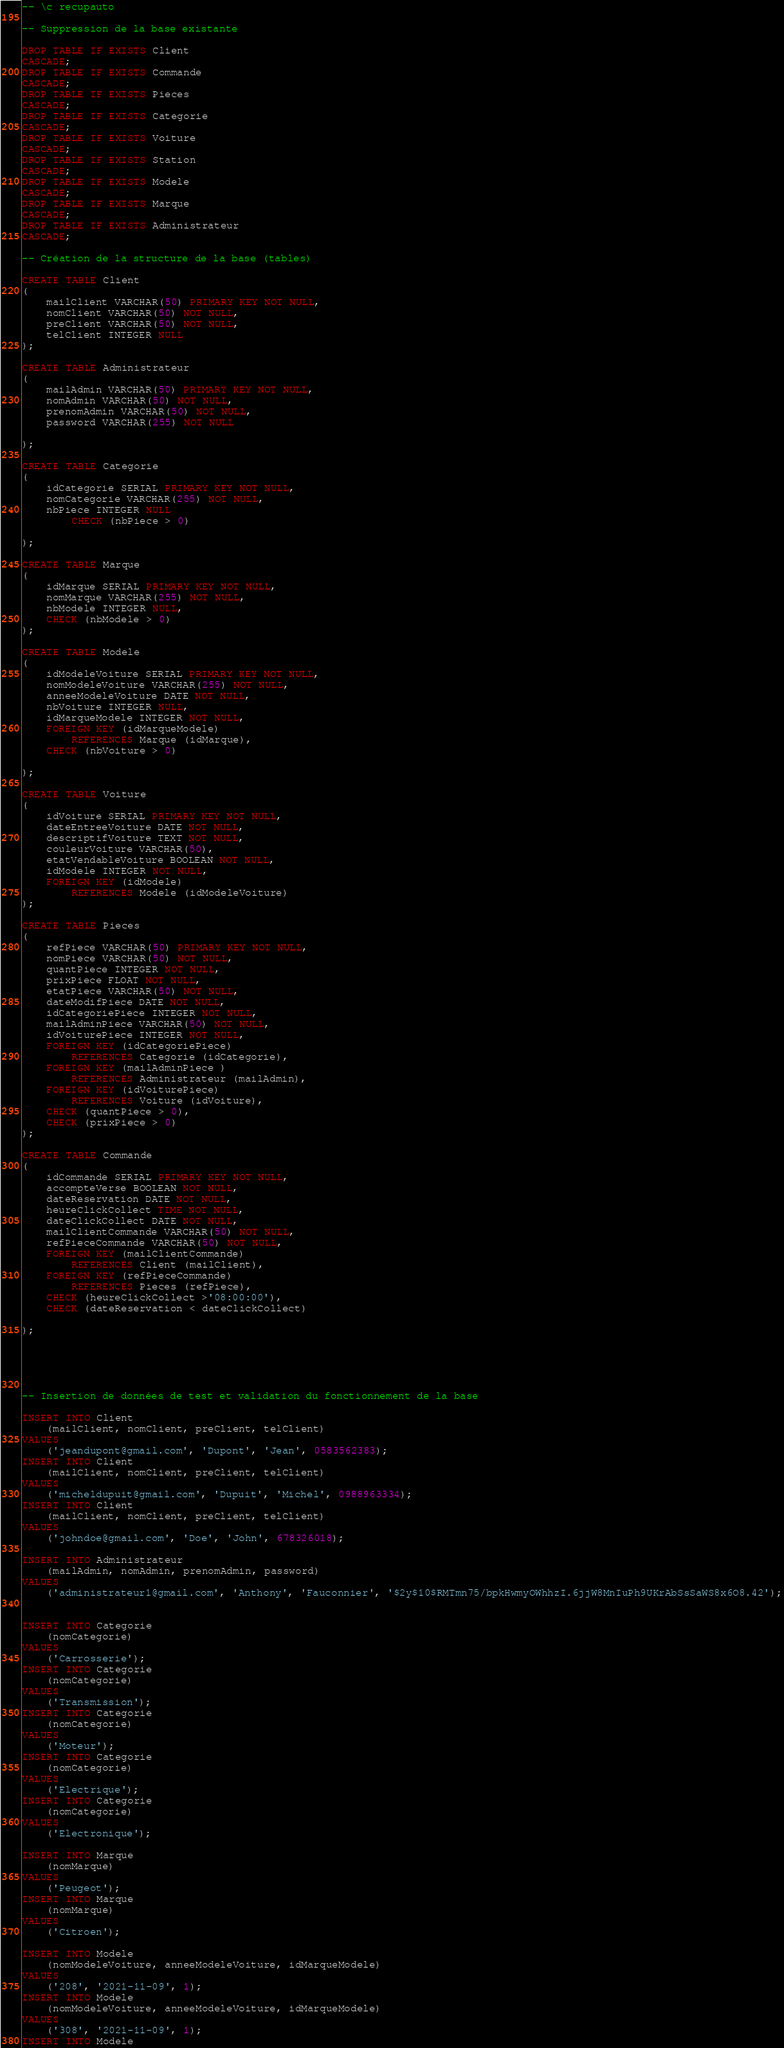<code> <loc_0><loc_0><loc_500><loc_500><_SQL_>-- \c recupauto

-- Suppression de la base existante

DROP TABLE IF EXISTS Client
CASCADE;
DROP TABLE IF EXISTS Commande
CASCADE;
DROP TABLE IF EXISTS Pieces
CASCADE;
DROP TABLE IF EXISTS Categorie
CASCADE;
DROP TABLE IF EXISTS Voiture
CASCADE;
DROP TABLE IF EXISTS Station
CASCADE;
DROP TABLE IF EXISTS Modele
CASCADE;
DROP TABLE IF EXISTS Marque
CASCADE;
DROP TABLE IF EXISTS Administrateur
CASCADE;

-- Création de la structure de la base (tables)

CREATE TABLE Client
(
    mailClient VARCHAR(50) PRIMARY KEY NOT NULL,
    nomClient VARCHAR(50) NOT NULL,
    preClient VARCHAR(50) NOT NULL,
    telClient INTEGER NULL
);

CREATE TABLE Administrateur
(
    mailAdmin VARCHAR(50) PRIMARY KEY NOT NULL,
    nomAdmin VARCHAR(50) NOT NULL,
    prenomAdmin VARCHAR(50) NOT NULL,
    password VARCHAR(255) NOT NULL

);

CREATE TABLE Categorie
(
    idCategorie SERIAL PRIMARY KEY NOT NULL,
    nomCategorie VARCHAR(255) NOT NULL,
    nbPiece INTEGER NULL
        CHECK (nbPiece > 0)

);

CREATE TABLE Marque
(
    idMarque SERIAL PRIMARY KEY NOT NULL,
    nomMarque VARCHAR(255) NOT NULL,
    nbModele INTEGER NULL,
    CHECK (nbModele > 0)
);

CREATE TABLE Modele
(
    idModeleVoiture SERIAL PRIMARY KEY NOT NULL,
    nomModeleVoiture VARCHAR(255) NOT NULL,
    anneeModeleVoiture DATE NOT NULL,
    nbVoiture INTEGER NULL,
    idMarqueModele INTEGER NOT NULL,
    FOREIGN KEY (idMarqueModele)
        REFERENCES Marque (idMarque),
    CHECK (nbVoiture > 0)

);

CREATE TABLE Voiture
(
    idVoiture SERIAL PRIMARY KEY NOT NULL,
    dateEntreeVoiture DATE NOT NULL,
    descriptifVoiture TEXT NOT NULL,
    couleurVoiture VARCHAR(50),
    etatVendableVoiture BOOLEAN NOT NULL,
    idModele INTEGER NOT NULL,
    FOREIGN KEY (idModele)
        REFERENCES Modele (idModeleVoiture)
);

CREATE TABLE Pieces
(
    refPiece VARCHAR(50) PRIMARY KEY NOT NULL,
    nomPiece VARCHAR(50) NOT NULL,
    quantPiece INTEGER NOT NULL,
    prixPiece FLOAT NOT NULL,
    etatPiece VARCHAR(50) NOT NULL,
    dateModifPiece DATE NOT NULL,
    idCategoriePiece INTEGER NOT NULL,
    mailAdminPiece VARCHAR(50) NOT NULL,
    idVoiturePiece INTEGER NOT NULL,
    FOREIGN KEY (idCategoriePiece)
        REFERENCES Categorie (idCategorie),
    FOREIGN KEY (mailAdminPiece )
        REFERENCES Administrateur (mailAdmin),
    FOREIGN KEY (idVoiturePiece)
        REFERENCES Voiture (idVoiture),
    CHECK (quantPiece > 0),
    CHECK (prixPiece > 0)
);

CREATE TABLE Commande
(
    idCommande SERIAL PRIMARY KEY NOT NULL,
    accompteVerse BOOLEAN NOT NULL,
    dateReservation DATE NOT NULL,
    heureClickCollect TIME NOT NULL,
    dateClickCollect DATE NOT NULL,
    mailClientCommande VARCHAR(50) NOT NULL,
    refPieceCommande VARCHAR(50) NOT NULL,
    FOREIGN KEY (mailClientCommande)
        REFERENCES Client (mailClient),
    FOREIGN KEY (refPieceCommande)
        REFERENCES Pieces (refPiece),
    CHECK (heureClickCollect >'08:00:00'),
    CHECK (dateReservation < dateClickCollect)

);





-- Insertion de données de test et validation du fonctionnement de la base

INSERT INTO Client
    (mailClient, nomClient, preClient, telClient)
VALUES
    ('jeandupont@gmail.com', 'Dupont', 'Jean', 0583562383);
INSERT INTO Client
    (mailClient, nomClient, preClient, telClient)
VALUES
    ('micheldupuit@gmail.com', 'Dupuit', 'Michel', 0988963334);
INSERT INTO Client
    (mailClient, nomClient, preClient, telClient)
VALUES
    ('johndoe@gmail.com', 'Doe', 'John', 678326018);

INSERT INTO Administrateur
    (mailAdmin, nomAdmin, prenomAdmin, password)
VALUES
    ('administrateur1@gmail.com', 'Anthony', 'Fauconnier', '$2y$10$RMTmn75/bpkHwmyOWhhzI.6jjW8MnIuPh9UKrAbSsSaWS8x6O8.42');


INSERT INTO Categorie
    (nomCategorie)
VALUES
    ('Carrosserie');
INSERT INTO Categorie
    (nomCategorie)
VALUES
    ('Transmission');
INSERT INTO Categorie
    (nomCategorie)
VALUES
    ('Moteur');
INSERT INTO Categorie
    (nomCategorie)
VALUES
    ('Electrique');
INSERT INTO Categorie
    (nomCategorie)
VALUES
    ('Electronique');

INSERT INTO Marque
    (nomMarque)
VALUES
    ('Peugeot');
INSERT INTO Marque
    (nomMarque)
VALUES
    ('Citroen');

INSERT INTO Modele
    (nomModeleVoiture, anneeModeleVoiture, idMarqueModele)
VALUES
    ('208', '2021-11-09', 1);
INSERT INTO Modele
    (nomModeleVoiture, anneeModeleVoiture, idMarqueModele)
VALUES
    ('308', '2021-11-09', 1);
INSERT INTO Modele</code> 